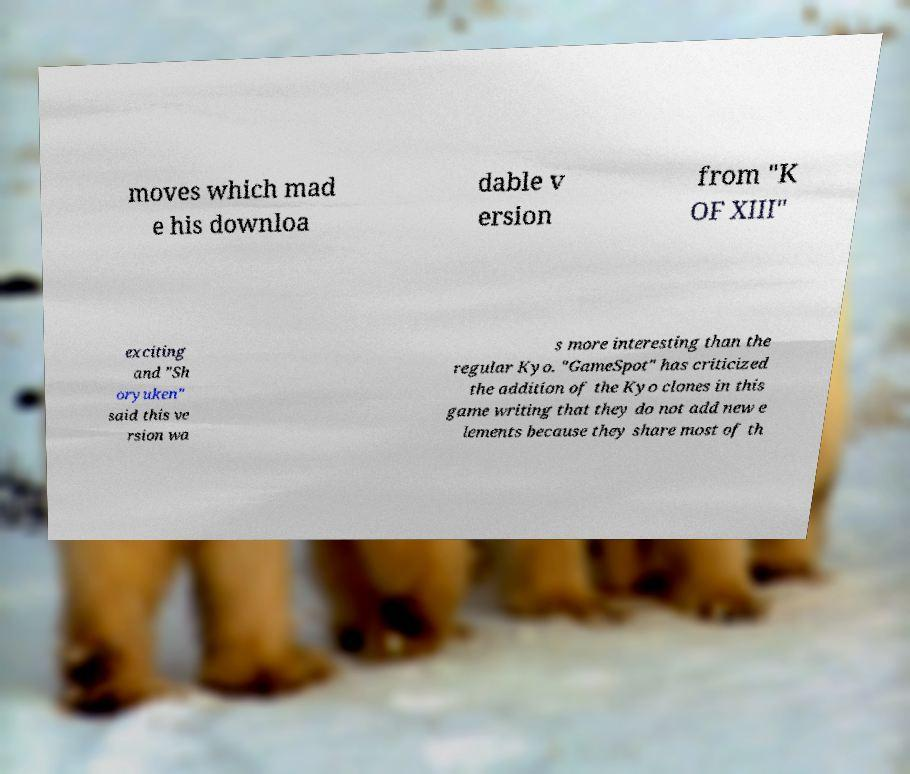Please read and relay the text visible in this image. What does it say? moves which mad e his downloa dable v ersion from "K OF XIII" exciting and "Sh oryuken" said this ve rsion wa s more interesting than the regular Kyo. "GameSpot" has criticized the addition of the Kyo clones in this game writing that they do not add new e lements because they share most of th 